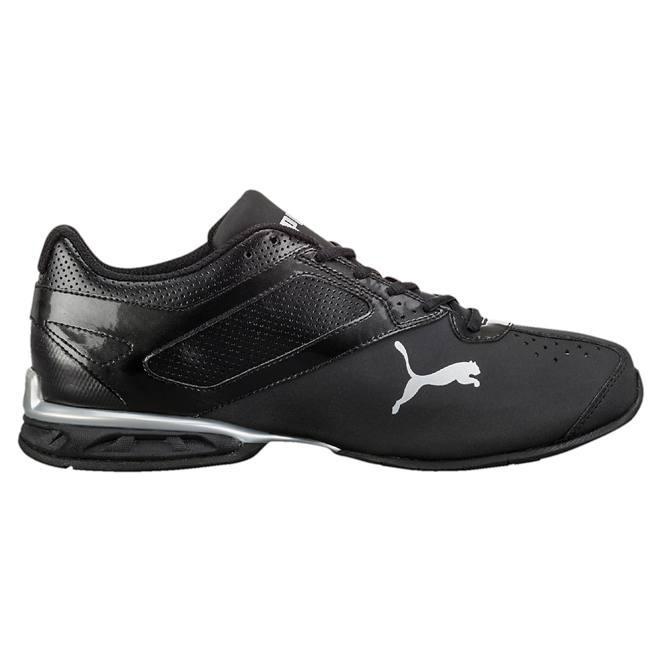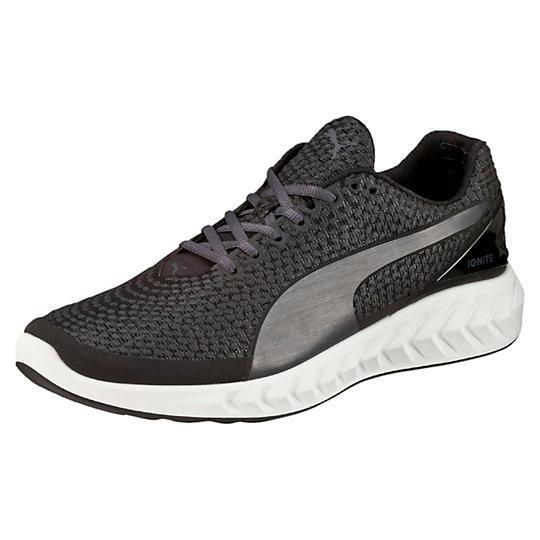The first image is the image on the left, the second image is the image on the right. Analyze the images presented: Is the assertion "All of the shoes are facing right." valid? Answer yes or no. No. The first image is the image on the left, the second image is the image on the right. Examine the images to the left and right. Is the description "all visible shoes have the toe side pointing towards the right" accurate? Answer yes or no. No. 